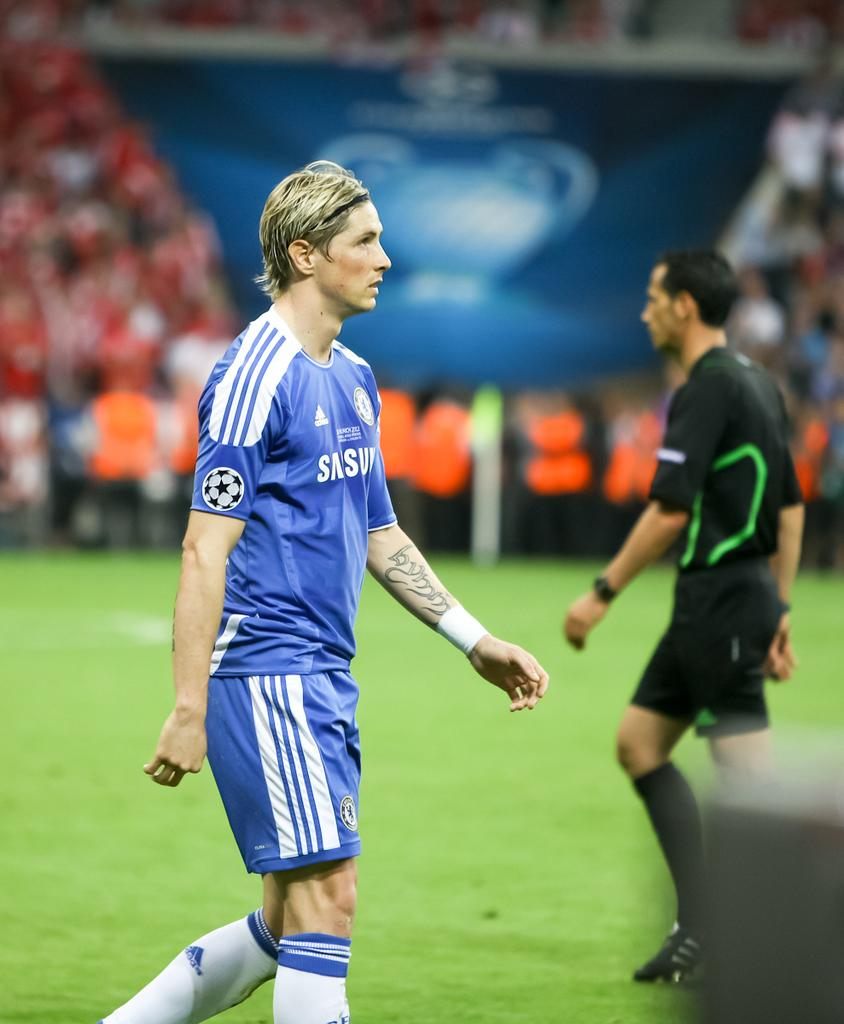How many people are in the image? There are two men in the image. What are the men doing in the image? The men are on the ground. What type of clothing are the men wearing on their upper bodies? The men are wearing jerseys. What type of clothing are the men wearing on their lower bodies? The men are wearing shorts. What type of footwear are the men wearing? The men are wearing footwear. Can you describe the background of the image? The background of the image is blurred. What letter can be seen on the men's jerseys in the image? There is no specific letter mentioned in the facts, and the image does not provide enough detail to identify any letters on the jerseys. 